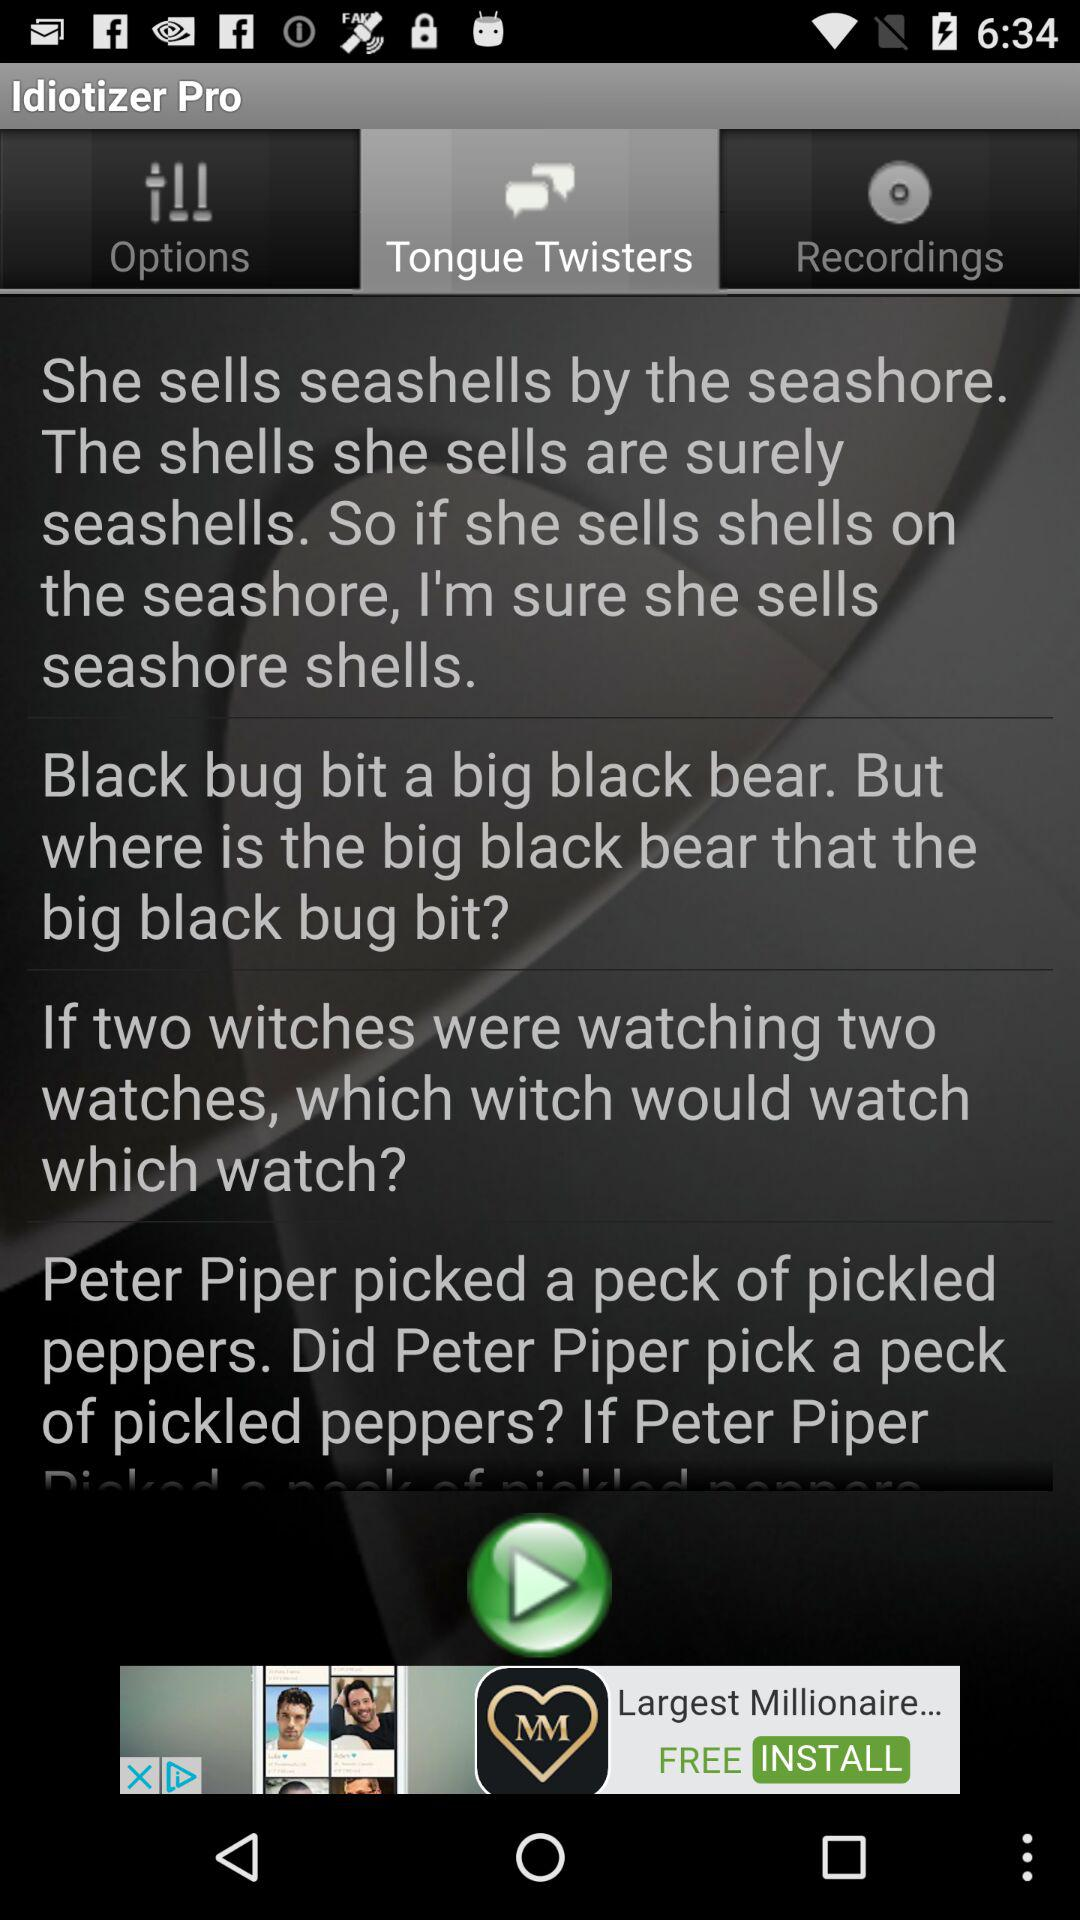Which tab is selected? The selected tab is "Tongue Twisters". 